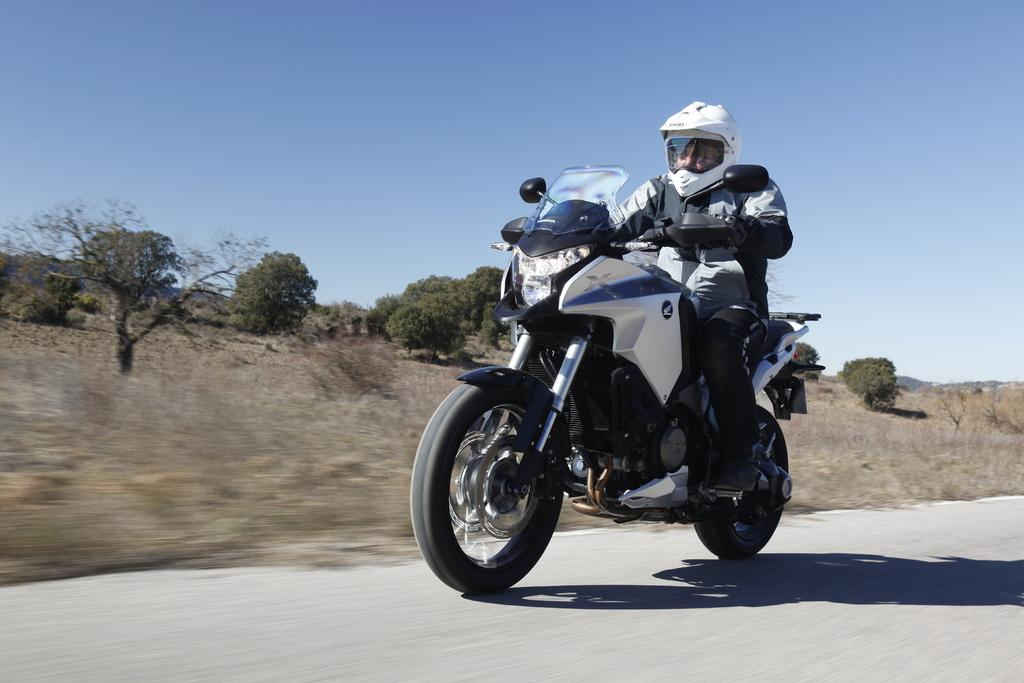Who or what is the main subject in the image? There is a person in the image. What is the person doing in the image? The person is sitting on a bike. Is the person wearing any protective gear in the image? Yes, the person is wearing a helmet. What can be seen in the background of the image? There are trees visible in the background of the image. How would you describe the weather based on the image? The sky is clear in the image, suggesting good weather. What type of marble is being used to decorate the bike in the image? There is no marble present in the image, and the bike is not being decorated with any marble. 